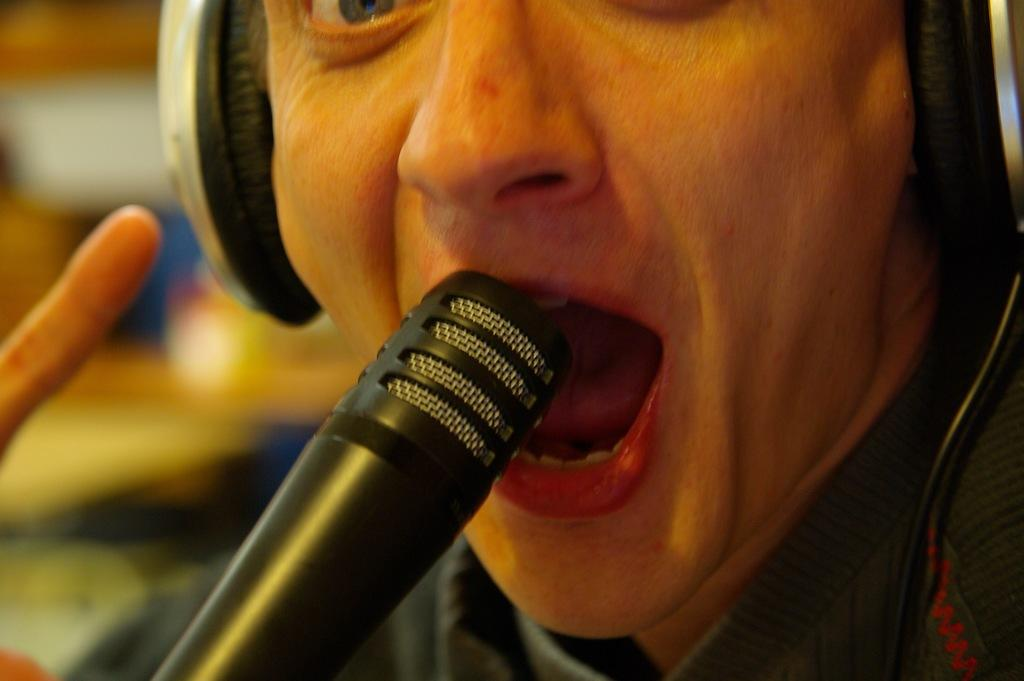Who or what is the main subject in the image? There is a person in the image. What is the person wearing? The person is wearing a headset. What object is in front of the person? There is a microphone in front of the person. Can you describe the background of the image? The background of the image is blurry. What shape is the rain forming in the image? There is no rain present in the image, so it is not possible to determine the shape of any rain. 